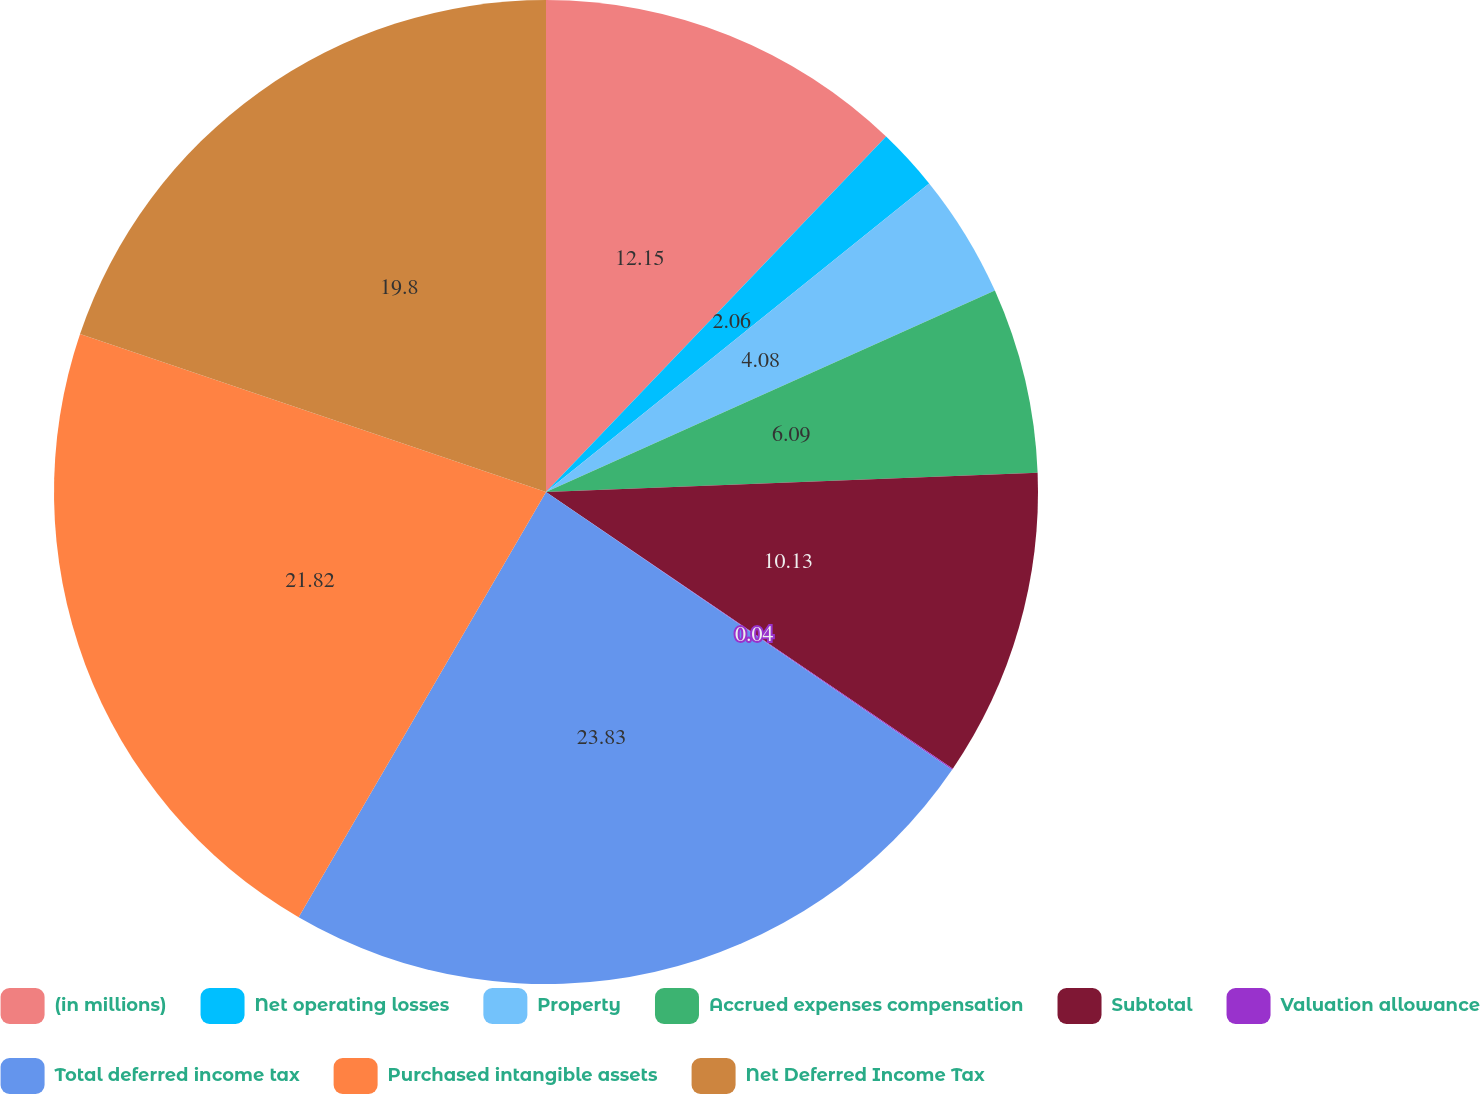<chart> <loc_0><loc_0><loc_500><loc_500><pie_chart><fcel>(in millions)<fcel>Net operating losses<fcel>Property<fcel>Accrued expenses compensation<fcel>Subtotal<fcel>Valuation allowance<fcel>Total deferred income tax<fcel>Purchased intangible assets<fcel>Net Deferred Income Tax<nl><fcel>12.15%<fcel>2.06%<fcel>4.08%<fcel>6.09%<fcel>10.13%<fcel>0.04%<fcel>23.84%<fcel>21.82%<fcel>19.8%<nl></chart> 